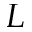Convert formula to latex. <formula><loc_0><loc_0><loc_500><loc_500>L</formula> 